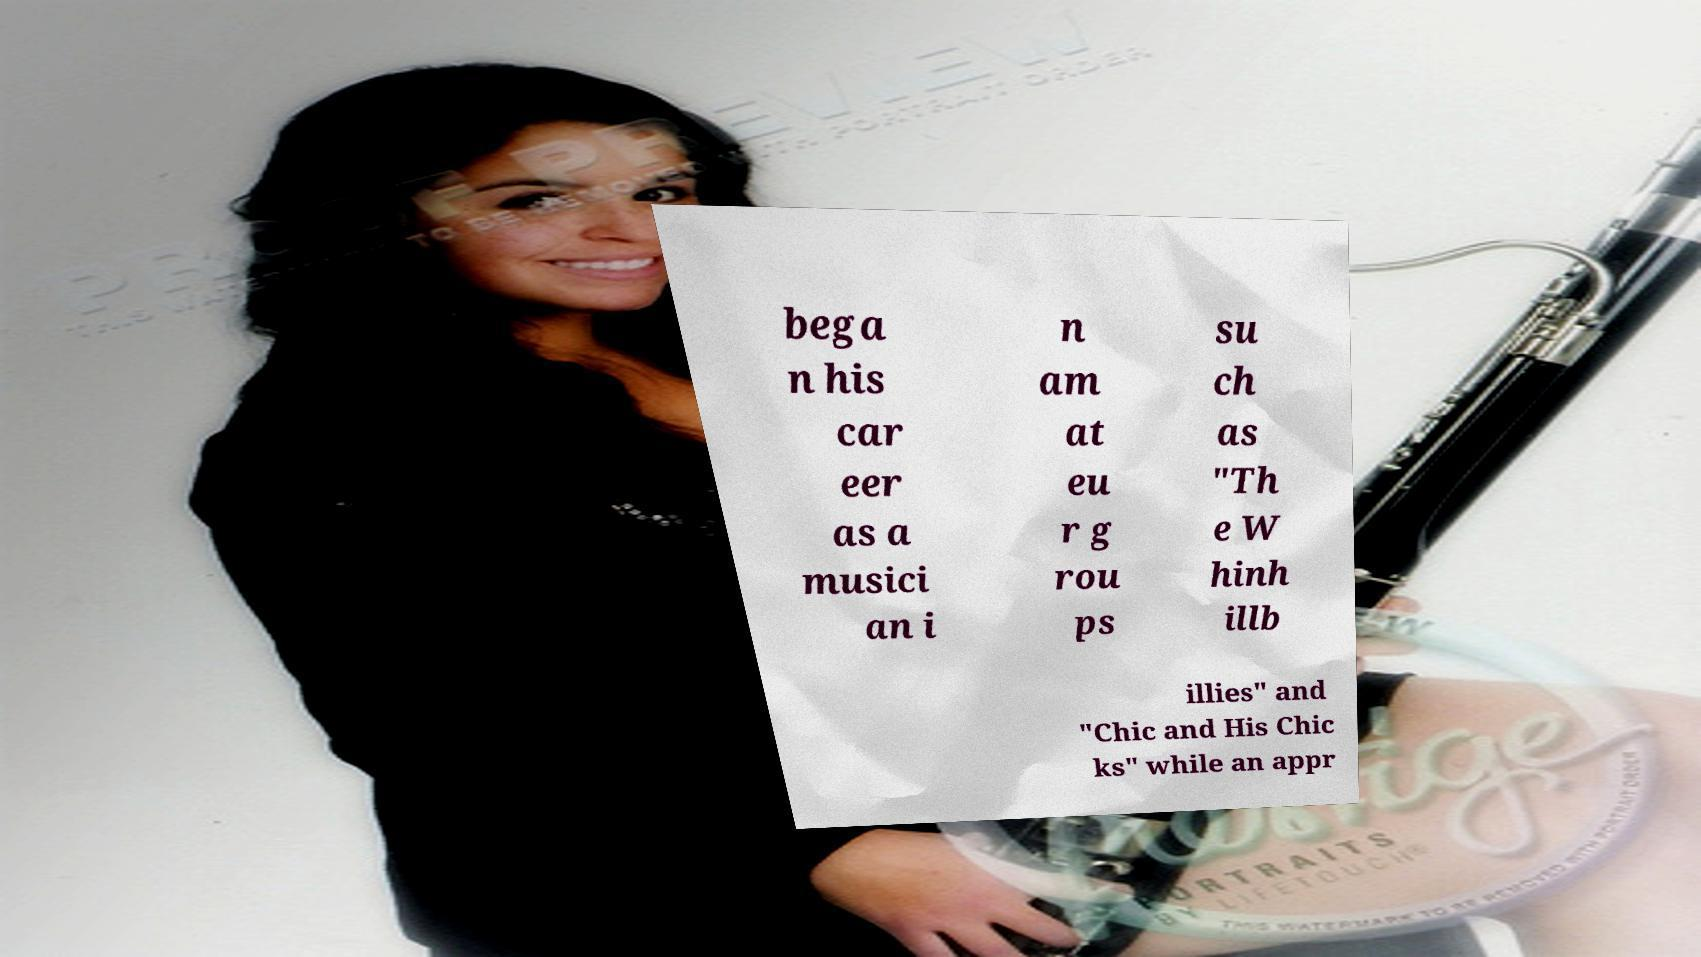Please identify and transcribe the text found in this image. bega n his car eer as a musici an i n am at eu r g rou ps su ch as "Th e W hinh illb illies" and "Chic and His Chic ks" while an appr 